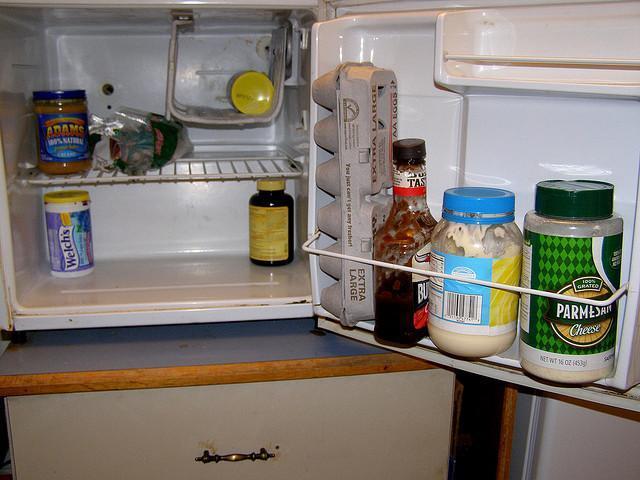How many bottles are in the photo?
Give a very brief answer. 6. 